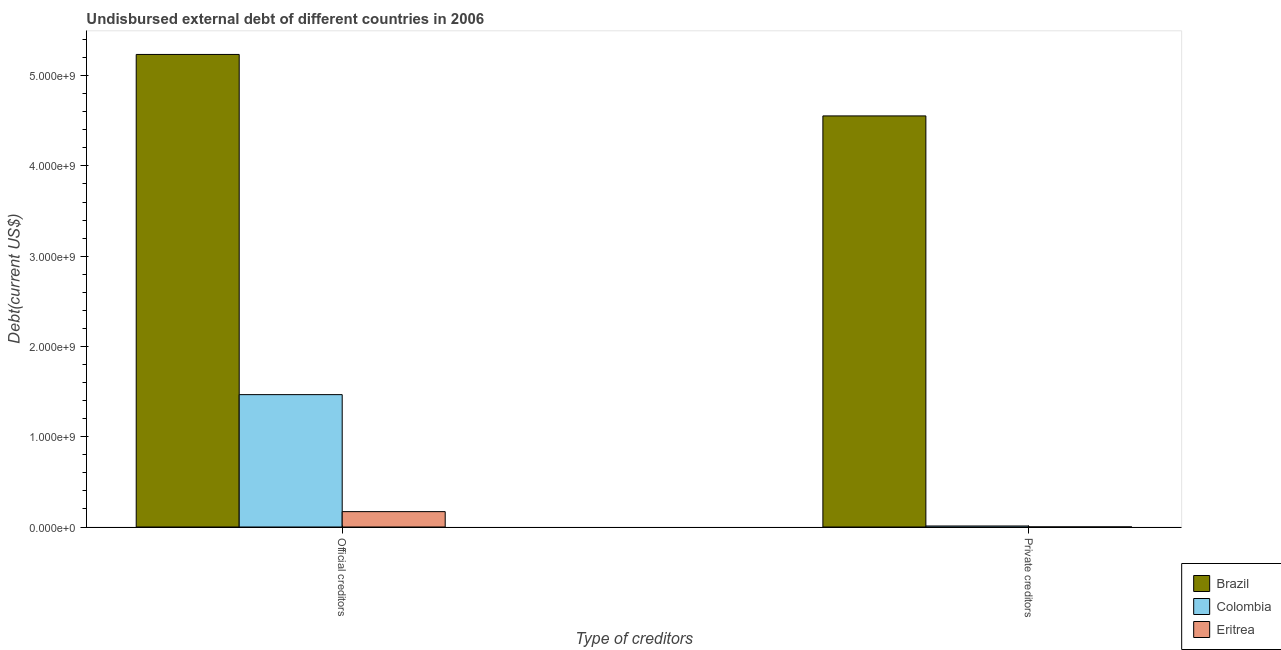How many groups of bars are there?
Make the answer very short. 2. Are the number of bars per tick equal to the number of legend labels?
Offer a terse response. Yes. Are the number of bars on each tick of the X-axis equal?
Provide a succinct answer. Yes. How many bars are there on the 1st tick from the left?
Your answer should be very brief. 3. How many bars are there on the 1st tick from the right?
Keep it short and to the point. 3. What is the label of the 1st group of bars from the left?
Offer a terse response. Official creditors. What is the undisbursed external debt of private creditors in Brazil?
Keep it short and to the point. 4.55e+09. Across all countries, what is the maximum undisbursed external debt of official creditors?
Provide a short and direct response. 5.23e+09. Across all countries, what is the minimum undisbursed external debt of official creditors?
Ensure brevity in your answer.  1.70e+08. In which country was the undisbursed external debt of official creditors minimum?
Keep it short and to the point. Eritrea. What is the total undisbursed external debt of private creditors in the graph?
Your response must be concise. 4.57e+09. What is the difference between the undisbursed external debt of official creditors in Brazil and that in Eritrea?
Your answer should be compact. 5.06e+09. What is the difference between the undisbursed external debt of private creditors in Colombia and the undisbursed external debt of official creditors in Brazil?
Your response must be concise. -5.22e+09. What is the average undisbursed external debt of private creditors per country?
Provide a succinct answer. 1.52e+09. What is the difference between the undisbursed external debt of private creditors and undisbursed external debt of official creditors in Brazil?
Your response must be concise. -6.81e+08. In how many countries, is the undisbursed external debt of private creditors greater than 1200000000 US$?
Your response must be concise. 1. What is the ratio of the undisbursed external debt of official creditors in Eritrea to that in Brazil?
Ensure brevity in your answer.  0.03. What does the 3rd bar from the right in Private creditors represents?
Offer a very short reply. Brazil. How many bars are there?
Make the answer very short. 6. Are all the bars in the graph horizontal?
Offer a terse response. No. How many countries are there in the graph?
Your answer should be very brief. 3. Are the values on the major ticks of Y-axis written in scientific E-notation?
Ensure brevity in your answer.  Yes. Where does the legend appear in the graph?
Make the answer very short. Bottom right. What is the title of the graph?
Your response must be concise. Undisbursed external debt of different countries in 2006. What is the label or title of the X-axis?
Ensure brevity in your answer.  Type of creditors. What is the label or title of the Y-axis?
Make the answer very short. Debt(current US$). What is the Debt(current US$) of Brazil in Official creditors?
Your answer should be very brief. 5.23e+09. What is the Debt(current US$) in Colombia in Official creditors?
Make the answer very short. 1.47e+09. What is the Debt(current US$) in Eritrea in Official creditors?
Your response must be concise. 1.70e+08. What is the Debt(current US$) of Brazil in Private creditors?
Offer a very short reply. 4.55e+09. What is the Debt(current US$) in Colombia in Private creditors?
Make the answer very short. 1.12e+07. What is the Debt(current US$) of Eritrea in Private creditors?
Keep it short and to the point. 7.23e+05. Across all Type of creditors, what is the maximum Debt(current US$) of Brazil?
Your answer should be very brief. 5.23e+09. Across all Type of creditors, what is the maximum Debt(current US$) of Colombia?
Offer a terse response. 1.47e+09. Across all Type of creditors, what is the maximum Debt(current US$) of Eritrea?
Your response must be concise. 1.70e+08. Across all Type of creditors, what is the minimum Debt(current US$) in Brazil?
Keep it short and to the point. 4.55e+09. Across all Type of creditors, what is the minimum Debt(current US$) of Colombia?
Ensure brevity in your answer.  1.12e+07. Across all Type of creditors, what is the minimum Debt(current US$) of Eritrea?
Ensure brevity in your answer.  7.23e+05. What is the total Debt(current US$) in Brazil in the graph?
Your response must be concise. 9.79e+09. What is the total Debt(current US$) in Colombia in the graph?
Your answer should be compact. 1.48e+09. What is the total Debt(current US$) of Eritrea in the graph?
Keep it short and to the point. 1.71e+08. What is the difference between the Debt(current US$) in Brazil in Official creditors and that in Private creditors?
Your answer should be very brief. 6.81e+08. What is the difference between the Debt(current US$) in Colombia in Official creditors and that in Private creditors?
Offer a terse response. 1.46e+09. What is the difference between the Debt(current US$) in Eritrea in Official creditors and that in Private creditors?
Offer a very short reply. 1.70e+08. What is the difference between the Debt(current US$) in Brazil in Official creditors and the Debt(current US$) in Colombia in Private creditors?
Offer a terse response. 5.22e+09. What is the difference between the Debt(current US$) in Brazil in Official creditors and the Debt(current US$) in Eritrea in Private creditors?
Provide a succinct answer. 5.23e+09. What is the difference between the Debt(current US$) in Colombia in Official creditors and the Debt(current US$) in Eritrea in Private creditors?
Ensure brevity in your answer.  1.47e+09. What is the average Debt(current US$) in Brazil per Type of creditors?
Offer a very short reply. 4.89e+09. What is the average Debt(current US$) in Colombia per Type of creditors?
Give a very brief answer. 7.39e+08. What is the average Debt(current US$) of Eritrea per Type of creditors?
Keep it short and to the point. 8.56e+07. What is the difference between the Debt(current US$) of Brazil and Debt(current US$) of Colombia in Official creditors?
Your answer should be very brief. 3.77e+09. What is the difference between the Debt(current US$) of Brazil and Debt(current US$) of Eritrea in Official creditors?
Ensure brevity in your answer.  5.06e+09. What is the difference between the Debt(current US$) in Colombia and Debt(current US$) in Eritrea in Official creditors?
Your response must be concise. 1.30e+09. What is the difference between the Debt(current US$) of Brazil and Debt(current US$) of Colombia in Private creditors?
Your answer should be very brief. 4.54e+09. What is the difference between the Debt(current US$) in Brazil and Debt(current US$) in Eritrea in Private creditors?
Provide a short and direct response. 4.55e+09. What is the difference between the Debt(current US$) of Colombia and Debt(current US$) of Eritrea in Private creditors?
Make the answer very short. 1.05e+07. What is the ratio of the Debt(current US$) in Brazil in Official creditors to that in Private creditors?
Ensure brevity in your answer.  1.15. What is the ratio of the Debt(current US$) of Colombia in Official creditors to that in Private creditors?
Your answer should be compact. 130.6. What is the ratio of the Debt(current US$) in Eritrea in Official creditors to that in Private creditors?
Give a very brief answer. 235.72. What is the difference between the highest and the second highest Debt(current US$) in Brazil?
Your answer should be compact. 6.81e+08. What is the difference between the highest and the second highest Debt(current US$) of Colombia?
Your answer should be very brief. 1.46e+09. What is the difference between the highest and the second highest Debt(current US$) of Eritrea?
Your answer should be compact. 1.70e+08. What is the difference between the highest and the lowest Debt(current US$) in Brazil?
Your answer should be compact. 6.81e+08. What is the difference between the highest and the lowest Debt(current US$) in Colombia?
Your answer should be compact. 1.46e+09. What is the difference between the highest and the lowest Debt(current US$) of Eritrea?
Give a very brief answer. 1.70e+08. 